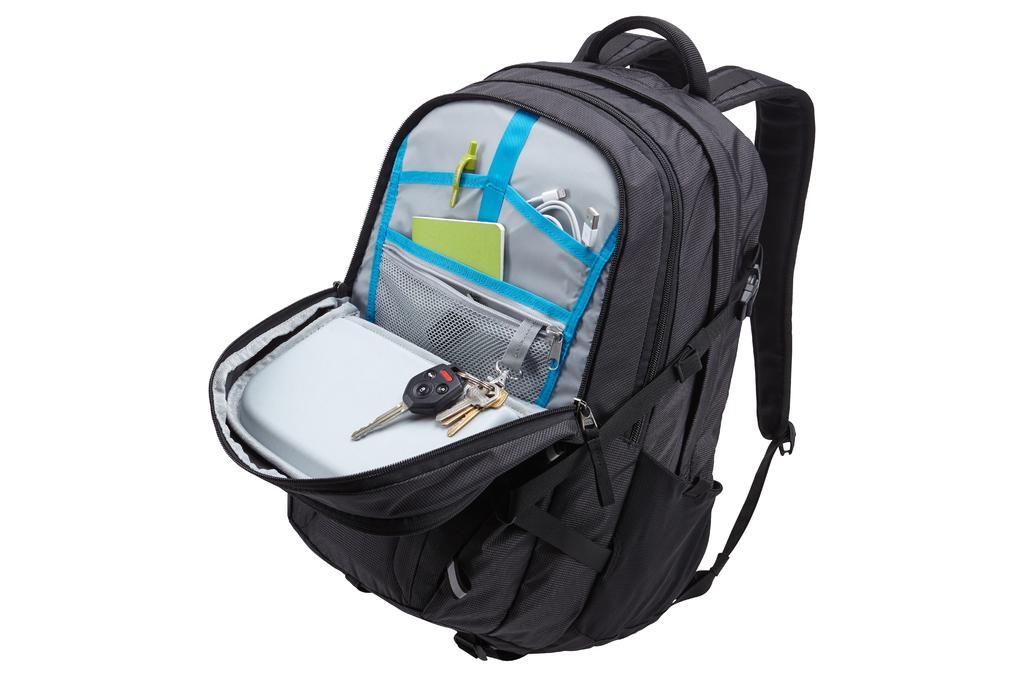In one or two sentences, can you explain what this image depicts? This is the picture of a backpack which is black in color and a zip of it is open and in that there is a key, wire and a notebook. 